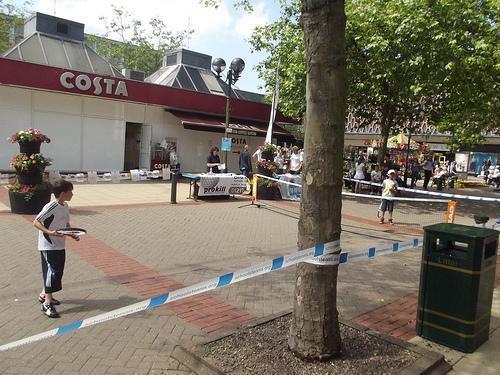How many trash bins are there?
Give a very brief answer. 1. 